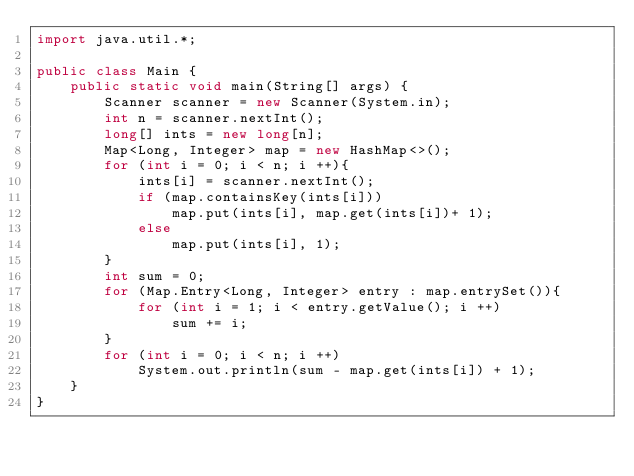<code> <loc_0><loc_0><loc_500><loc_500><_Java_>import java.util.*;

public class Main {
    public static void main(String[] args) {
        Scanner scanner = new Scanner(System.in);
        int n = scanner.nextInt();
        long[] ints = new long[n];
        Map<Long, Integer> map = new HashMap<>();
        for (int i = 0; i < n; i ++){
            ints[i] = scanner.nextInt();
            if (map.containsKey(ints[i]))
                map.put(ints[i], map.get(ints[i])+ 1);
            else
                map.put(ints[i], 1);
        }
        int sum = 0;
        for (Map.Entry<Long, Integer> entry : map.entrySet()){
            for (int i = 1; i < entry.getValue(); i ++)
                sum += i;
        }
        for (int i = 0; i < n; i ++)
            System.out.println(sum - map.get(ints[i]) + 1);
    }
}
</code> 